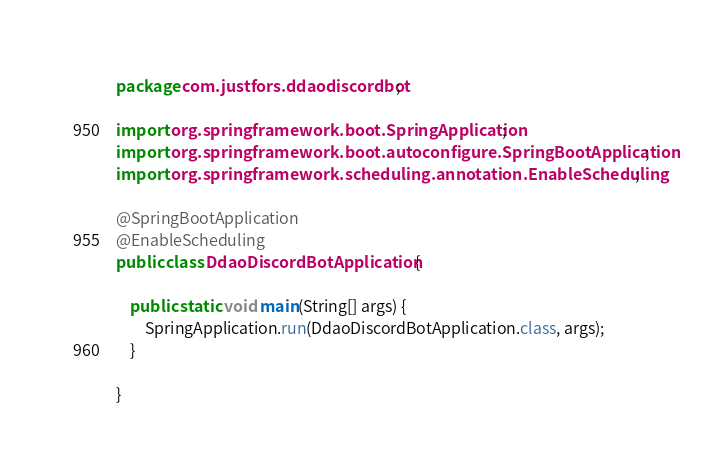<code> <loc_0><loc_0><loc_500><loc_500><_Java_>package com.justfors.ddaodiscordbot;

import org.springframework.boot.SpringApplication;
import org.springframework.boot.autoconfigure.SpringBootApplication;
import org.springframework.scheduling.annotation.EnableScheduling;

@SpringBootApplication
@EnableScheduling
public class DdaoDiscordBotApplication {

	public static void main(String[] args) {
		SpringApplication.run(DdaoDiscordBotApplication.class, args);
	}

}
</code> 